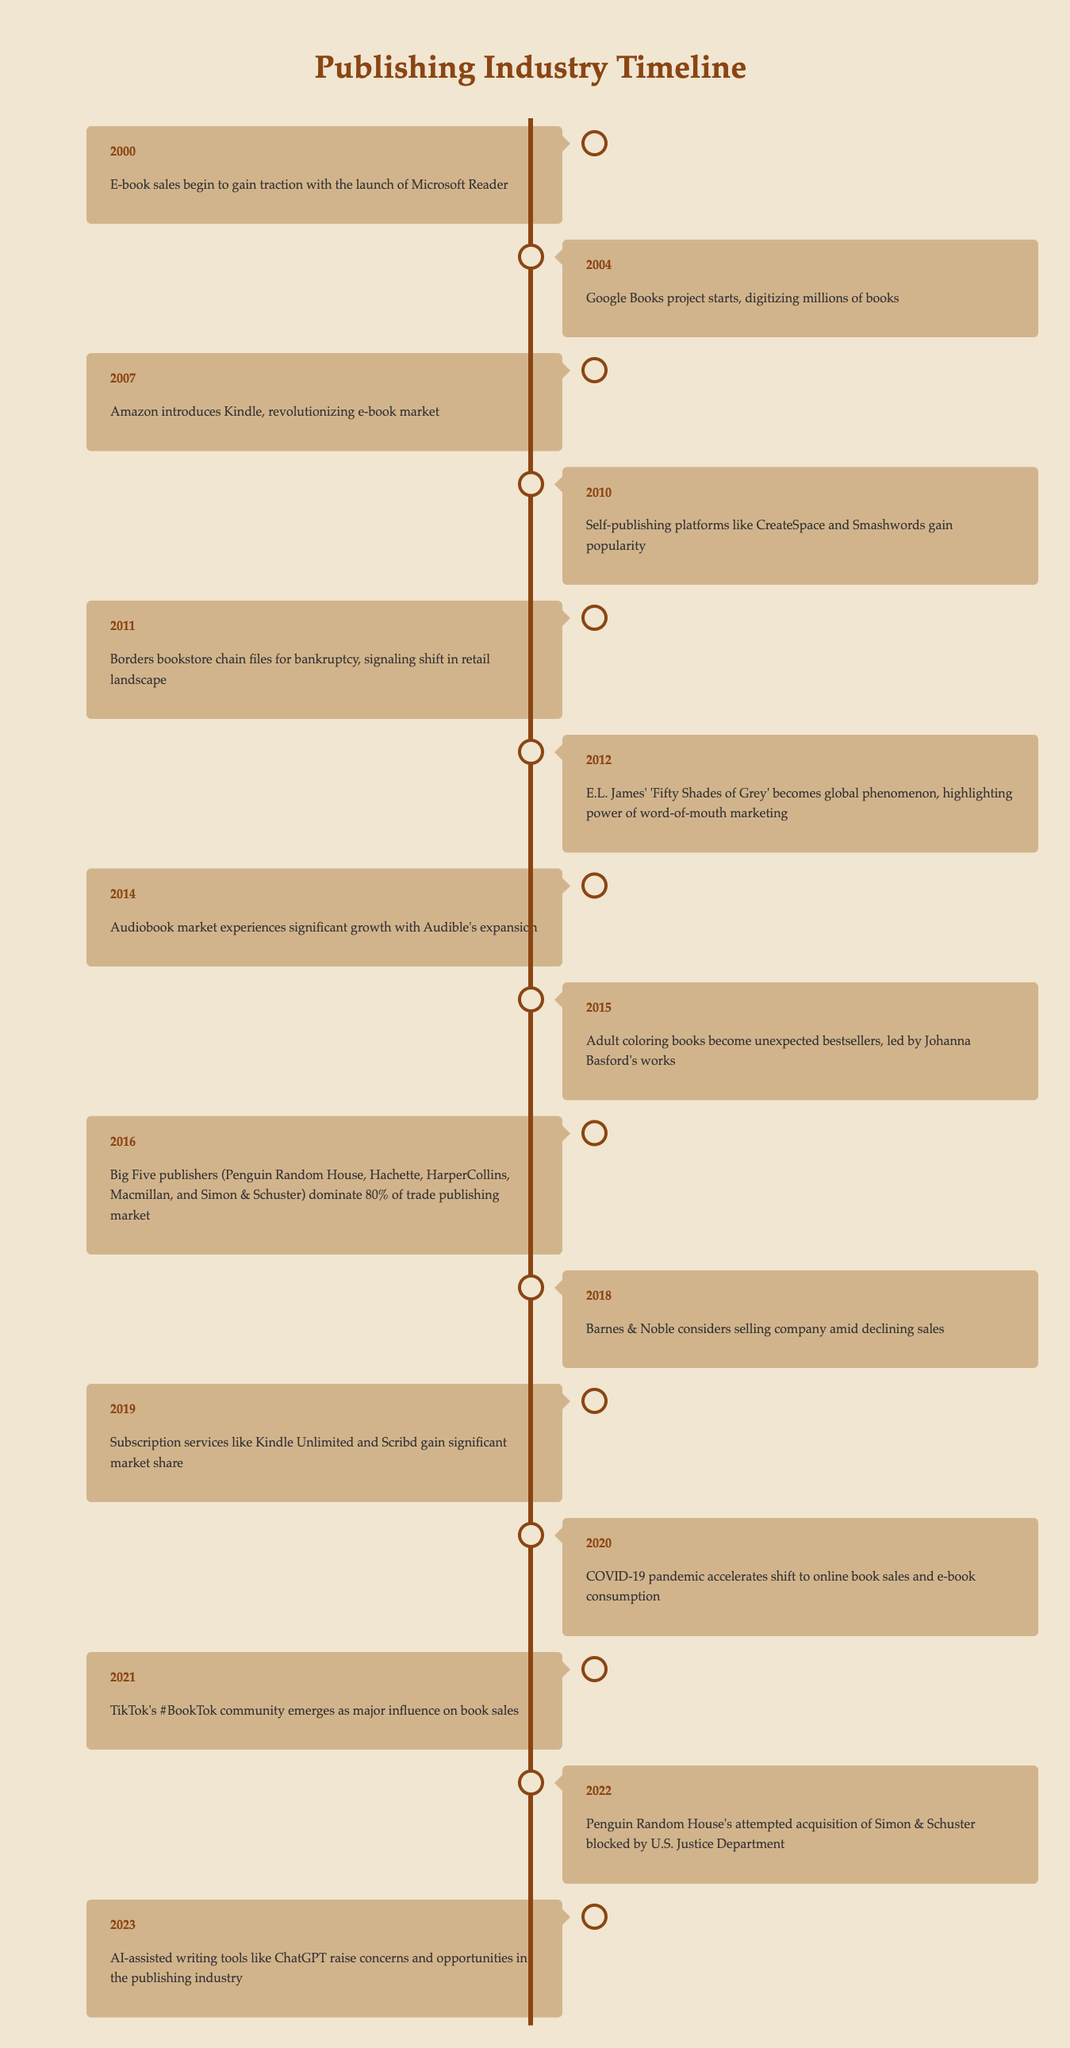What year did the Amazon Kindle launch? The table lists the year 2007 as the time Amazon introduced the Kindle, which is highlighted under its event description.
Answer: 2007 What significant event occurred in 2011 related to a bookstore chain? The event listed for 2011 states that Borders bookstore chain filed for bankruptcy, indicating a critical shift in the retail landscape.
Answer: Borders bookstore chain files for bankruptcy How many years passed between the launch of the Kindle and the emergence of TikTok's #BookTok community? The Kindle launched in 2007, and the #BookTok community emerged in 2021. The difference is 2021 - 2007 = 14 years.
Answer: 14 years Which event in 2012 emphasized the impact of word-of-mouth marketing? The event listed in 2012 states that E.L. James' 'Fifty Shades of Grey' became a global phenomenon, highlighting the power of word-of-mouth marketing.
Answer: E.L. James' 'Fifty Shades of Grey' becomes a global phenomenon Was 2020 marked by an acceleration towards online book sales due to a pandemic? The 2020 event notes that the COVID-19 pandemic accelerated the shift to online book sales and e-book consumption, confirming that this was indeed the case.
Answer: Yes What percentage of the trade publishing market was dominated by the Big Five publishers in 2016? According to the 2016 event, the Big Five publishers dominated 80% of the trade publishing market.
Answer: 80% How would you describe the growth of the audiobook market by 2014? The event from 2014 states that the audiobook market experienced significant growth with Audible's expansion, indicating a trend towards increased popularity for audiobooks.
Answer: Significant growth Was there a notable shift in the publishing market in 2012 related to a specific book? Yes, the event in 2012 discusses the impact of 'Fifty Shades of Grey' on global book sales and marketing strategies, which signifies a notable market shift.
Answer: Yes What started in 2019 that indicated a change in how books are consumed? In 2019, subscription services like Kindle Unlimited and Scribd gained significant market share, indicating a shift in reading habits and consumption models.
Answer: Subscription services gained significant market share In which year did the attempted acquisition of Simon & Schuster by Penguin Random House get blocked? The table indicates that this acquisition attempt was blocked in 2022.
Answer: 2022 